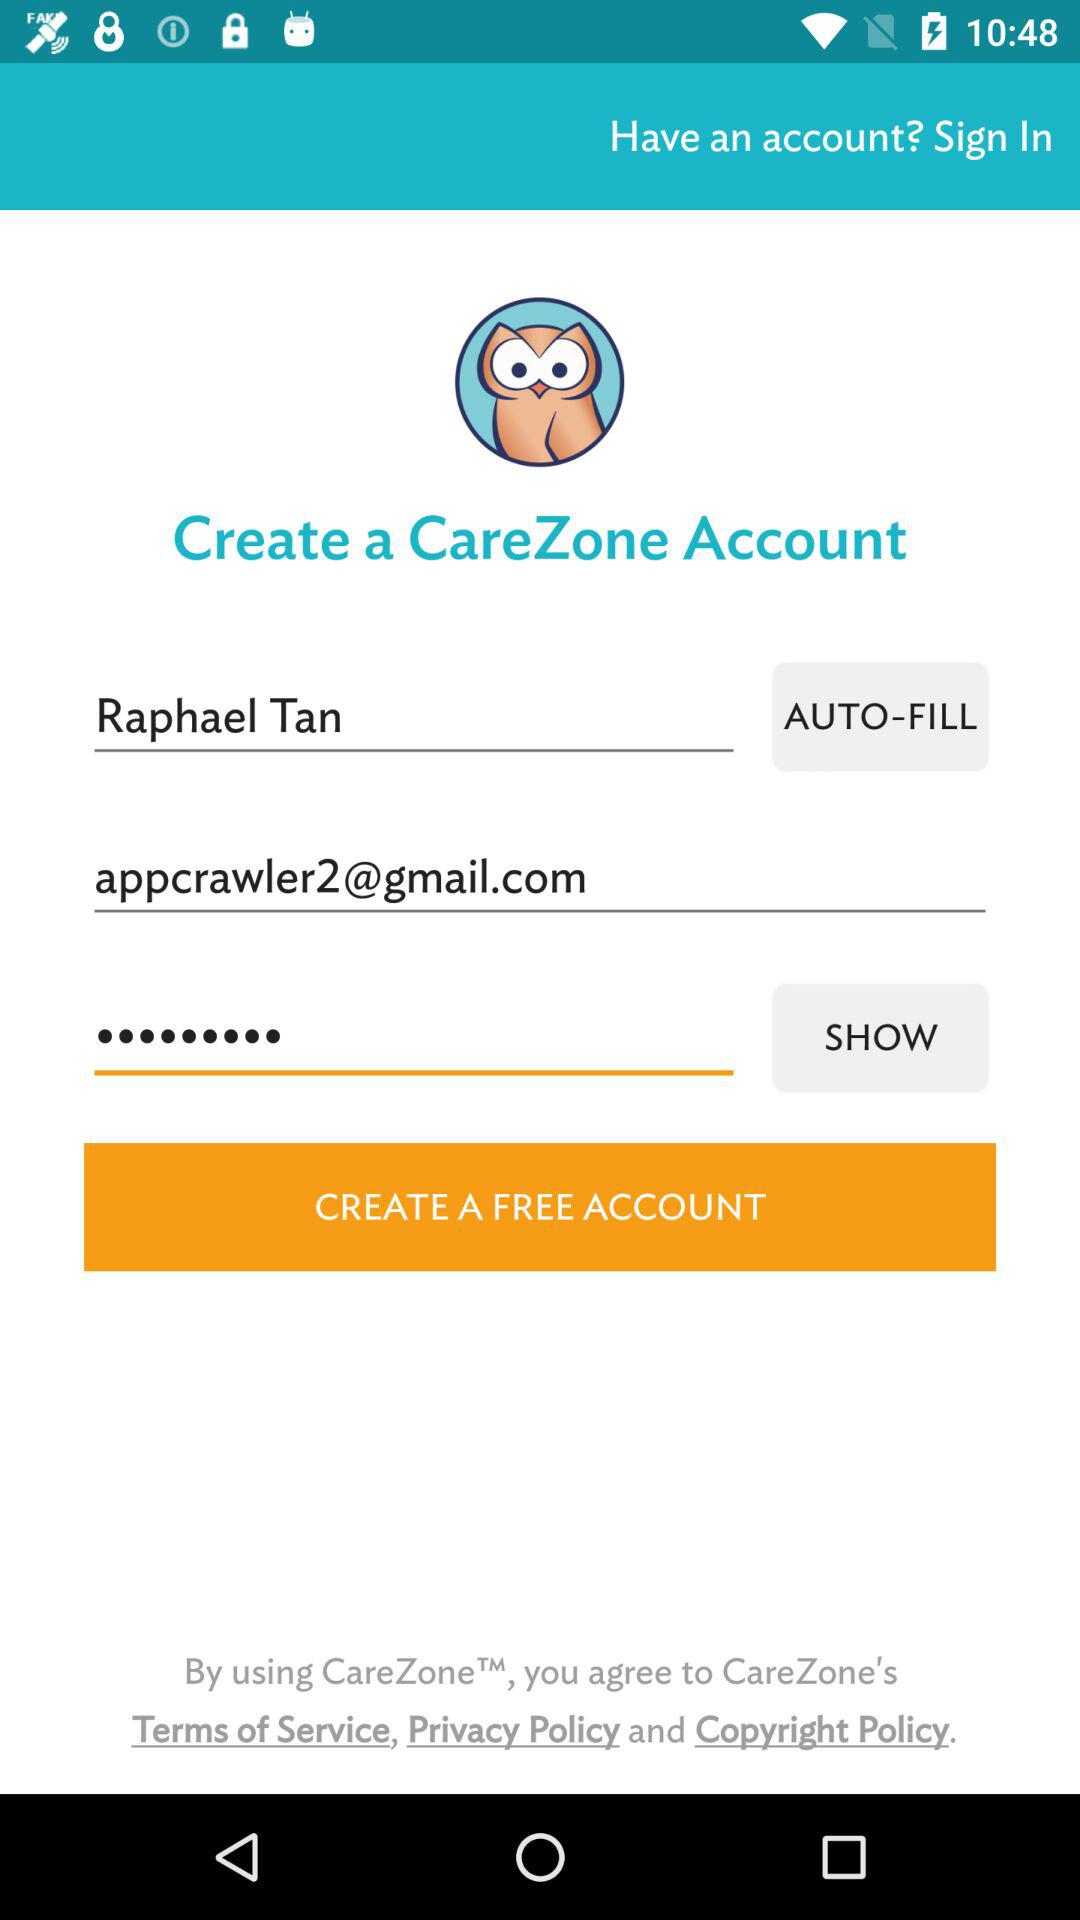What is the name of the application? The name of the application is "CareZone". 